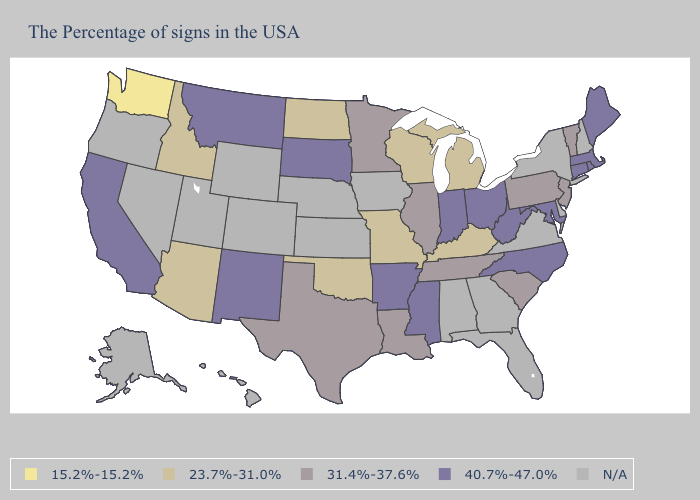Among the states that border Georgia , does North Carolina have the highest value?
Concise answer only. Yes. Does North Carolina have the highest value in the USA?
Be succinct. Yes. What is the value of South Dakota?
Short answer required. 40.7%-47.0%. Name the states that have a value in the range 31.4%-37.6%?
Be succinct. Vermont, New Jersey, Pennsylvania, South Carolina, Tennessee, Illinois, Louisiana, Minnesota, Texas. Which states have the lowest value in the USA?
Short answer required. Washington. Among the states that border Wisconsin , does Minnesota have the highest value?
Concise answer only. Yes. Does Oklahoma have the lowest value in the USA?
Short answer required. No. Name the states that have a value in the range 15.2%-15.2%?
Keep it brief. Washington. Does Maine have the highest value in the USA?
Quick response, please. Yes. Name the states that have a value in the range N/A?
Short answer required. New Hampshire, New York, Delaware, Virginia, Florida, Georgia, Alabama, Iowa, Kansas, Nebraska, Wyoming, Colorado, Utah, Nevada, Oregon, Alaska, Hawaii. What is the lowest value in the Northeast?
Be succinct. 31.4%-37.6%. What is the lowest value in the MidWest?
Be succinct. 23.7%-31.0%. 